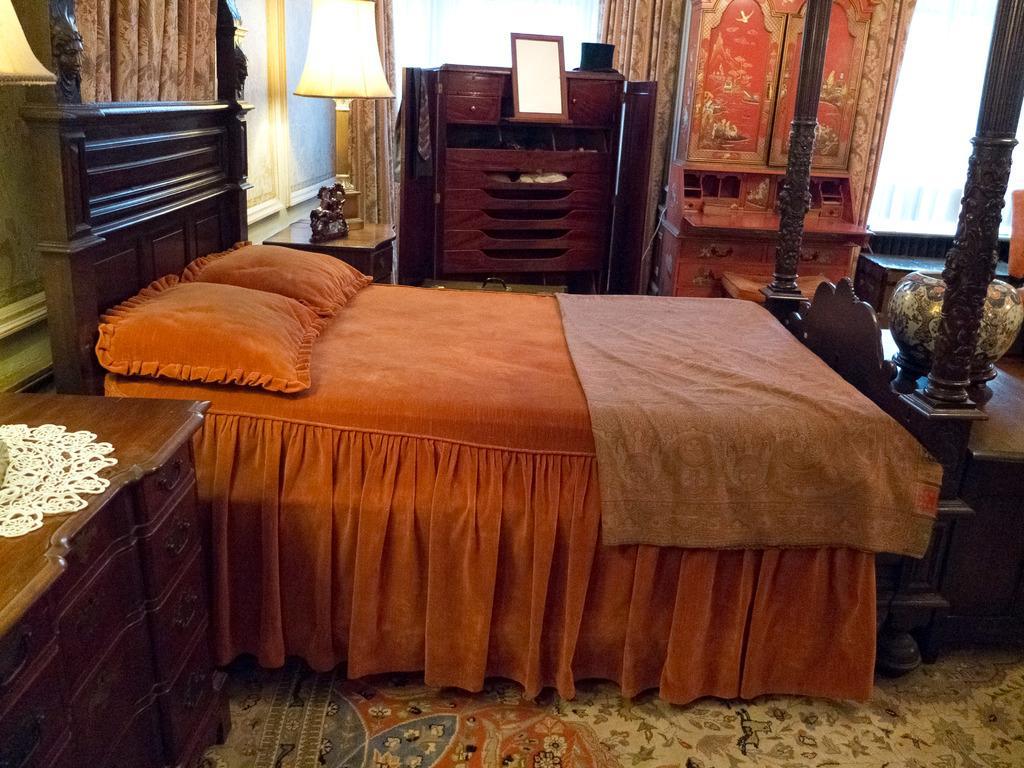How would you summarize this image in a sentence or two? In this picture we can see the inside view of a room. This is bed and these are the pillows. And there is a lamp. Here we can see a cupboard. 